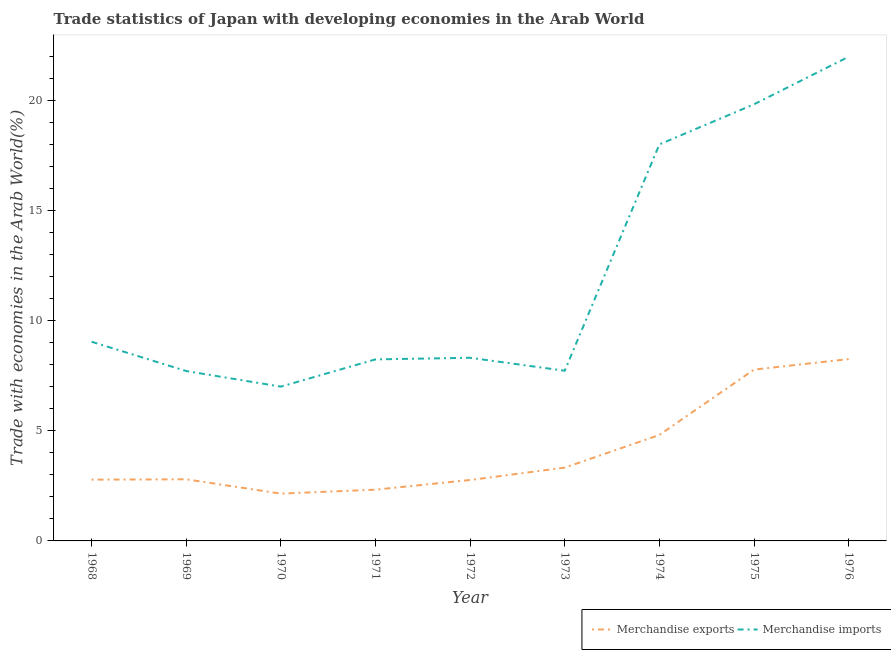Is the number of lines equal to the number of legend labels?
Provide a succinct answer. Yes. What is the merchandise imports in 1975?
Provide a succinct answer. 19.83. Across all years, what is the maximum merchandise imports?
Your response must be concise. 21.99. Across all years, what is the minimum merchandise exports?
Your answer should be very brief. 2.15. In which year was the merchandise imports maximum?
Ensure brevity in your answer.  1976. What is the total merchandise imports in the graph?
Offer a very short reply. 107.87. What is the difference between the merchandise exports in 1971 and that in 1976?
Provide a short and direct response. -5.93. What is the difference between the merchandise exports in 1975 and the merchandise imports in 1969?
Make the answer very short. 0.07. What is the average merchandise exports per year?
Make the answer very short. 4.11. In the year 1973, what is the difference between the merchandise exports and merchandise imports?
Offer a very short reply. -4.4. What is the ratio of the merchandise imports in 1969 to that in 1972?
Your answer should be compact. 0.93. What is the difference between the highest and the second highest merchandise exports?
Give a very brief answer. 0.48. What is the difference between the highest and the lowest merchandise exports?
Provide a succinct answer. 6.11. Is the sum of the merchandise imports in 1972 and 1974 greater than the maximum merchandise exports across all years?
Give a very brief answer. Yes. Does the merchandise exports monotonically increase over the years?
Give a very brief answer. No. What is the difference between two consecutive major ticks on the Y-axis?
Your response must be concise. 5. Are the values on the major ticks of Y-axis written in scientific E-notation?
Your answer should be very brief. No. Where does the legend appear in the graph?
Offer a very short reply. Bottom right. How many legend labels are there?
Keep it short and to the point. 2. How are the legend labels stacked?
Keep it short and to the point. Horizontal. What is the title of the graph?
Your answer should be very brief. Trade statistics of Japan with developing economies in the Arab World. What is the label or title of the Y-axis?
Keep it short and to the point. Trade with economies in the Arab World(%). What is the Trade with economies in the Arab World(%) in Merchandise exports in 1968?
Your answer should be very brief. 2.78. What is the Trade with economies in the Arab World(%) in Merchandise imports in 1968?
Make the answer very short. 9.04. What is the Trade with economies in the Arab World(%) in Merchandise exports in 1969?
Give a very brief answer. 2.8. What is the Trade with economies in the Arab World(%) in Merchandise imports in 1969?
Offer a very short reply. 7.71. What is the Trade with economies in the Arab World(%) of Merchandise exports in 1970?
Provide a short and direct response. 2.15. What is the Trade with economies in the Arab World(%) of Merchandise imports in 1970?
Give a very brief answer. 7.01. What is the Trade with economies in the Arab World(%) of Merchandise exports in 1971?
Your answer should be very brief. 2.33. What is the Trade with economies in the Arab World(%) in Merchandise imports in 1971?
Your answer should be compact. 8.24. What is the Trade with economies in the Arab World(%) in Merchandise exports in 1972?
Offer a very short reply. 2.77. What is the Trade with economies in the Arab World(%) in Merchandise imports in 1972?
Ensure brevity in your answer.  8.32. What is the Trade with economies in the Arab World(%) in Merchandise exports in 1973?
Ensure brevity in your answer.  3.33. What is the Trade with economies in the Arab World(%) of Merchandise imports in 1973?
Make the answer very short. 7.73. What is the Trade with economies in the Arab World(%) in Merchandise exports in 1974?
Provide a short and direct response. 4.81. What is the Trade with economies in the Arab World(%) in Merchandise imports in 1974?
Give a very brief answer. 18. What is the Trade with economies in the Arab World(%) in Merchandise exports in 1975?
Make the answer very short. 7.78. What is the Trade with economies in the Arab World(%) of Merchandise imports in 1975?
Make the answer very short. 19.83. What is the Trade with economies in the Arab World(%) in Merchandise exports in 1976?
Keep it short and to the point. 8.26. What is the Trade with economies in the Arab World(%) of Merchandise imports in 1976?
Give a very brief answer. 21.99. Across all years, what is the maximum Trade with economies in the Arab World(%) of Merchandise exports?
Offer a terse response. 8.26. Across all years, what is the maximum Trade with economies in the Arab World(%) in Merchandise imports?
Your answer should be very brief. 21.99. Across all years, what is the minimum Trade with economies in the Arab World(%) in Merchandise exports?
Offer a terse response. 2.15. Across all years, what is the minimum Trade with economies in the Arab World(%) in Merchandise imports?
Keep it short and to the point. 7.01. What is the total Trade with economies in the Arab World(%) in Merchandise exports in the graph?
Provide a succinct answer. 37. What is the total Trade with economies in the Arab World(%) of Merchandise imports in the graph?
Keep it short and to the point. 107.87. What is the difference between the Trade with economies in the Arab World(%) of Merchandise exports in 1968 and that in 1969?
Ensure brevity in your answer.  -0.01. What is the difference between the Trade with economies in the Arab World(%) in Merchandise imports in 1968 and that in 1969?
Make the answer very short. 1.33. What is the difference between the Trade with economies in the Arab World(%) in Merchandise exports in 1968 and that in 1970?
Make the answer very short. 0.64. What is the difference between the Trade with economies in the Arab World(%) of Merchandise imports in 1968 and that in 1970?
Ensure brevity in your answer.  2.04. What is the difference between the Trade with economies in the Arab World(%) of Merchandise exports in 1968 and that in 1971?
Your answer should be compact. 0.46. What is the difference between the Trade with economies in the Arab World(%) of Merchandise imports in 1968 and that in 1971?
Give a very brief answer. 0.8. What is the difference between the Trade with economies in the Arab World(%) in Merchandise exports in 1968 and that in 1972?
Offer a terse response. 0.02. What is the difference between the Trade with economies in the Arab World(%) of Merchandise imports in 1968 and that in 1972?
Make the answer very short. 0.73. What is the difference between the Trade with economies in the Arab World(%) in Merchandise exports in 1968 and that in 1973?
Your answer should be very brief. -0.55. What is the difference between the Trade with economies in the Arab World(%) of Merchandise imports in 1968 and that in 1973?
Provide a short and direct response. 1.32. What is the difference between the Trade with economies in the Arab World(%) of Merchandise exports in 1968 and that in 1974?
Offer a very short reply. -2.03. What is the difference between the Trade with economies in the Arab World(%) in Merchandise imports in 1968 and that in 1974?
Offer a very short reply. -8.96. What is the difference between the Trade with economies in the Arab World(%) of Merchandise exports in 1968 and that in 1975?
Provide a succinct answer. -5. What is the difference between the Trade with economies in the Arab World(%) of Merchandise imports in 1968 and that in 1975?
Your answer should be very brief. -10.78. What is the difference between the Trade with economies in the Arab World(%) of Merchandise exports in 1968 and that in 1976?
Give a very brief answer. -5.47. What is the difference between the Trade with economies in the Arab World(%) of Merchandise imports in 1968 and that in 1976?
Offer a very short reply. -12.94. What is the difference between the Trade with economies in the Arab World(%) of Merchandise exports in 1969 and that in 1970?
Give a very brief answer. 0.65. What is the difference between the Trade with economies in the Arab World(%) in Merchandise imports in 1969 and that in 1970?
Offer a terse response. 0.71. What is the difference between the Trade with economies in the Arab World(%) of Merchandise exports in 1969 and that in 1971?
Ensure brevity in your answer.  0.47. What is the difference between the Trade with economies in the Arab World(%) in Merchandise imports in 1969 and that in 1971?
Your answer should be very brief. -0.53. What is the difference between the Trade with economies in the Arab World(%) in Merchandise exports in 1969 and that in 1972?
Your answer should be very brief. 0.03. What is the difference between the Trade with economies in the Arab World(%) in Merchandise imports in 1969 and that in 1972?
Your answer should be compact. -0.6. What is the difference between the Trade with economies in the Arab World(%) of Merchandise exports in 1969 and that in 1973?
Your response must be concise. -0.53. What is the difference between the Trade with economies in the Arab World(%) in Merchandise imports in 1969 and that in 1973?
Provide a short and direct response. -0.01. What is the difference between the Trade with economies in the Arab World(%) of Merchandise exports in 1969 and that in 1974?
Offer a terse response. -2.01. What is the difference between the Trade with economies in the Arab World(%) in Merchandise imports in 1969 and that in 1974?
Your answer should be very brief. -10.29. What is the difference between the Trade with economies in the Arab World(%) in Merchandise exports in 1969 and that in 1975?
Make the answer very short. -4.98. What is the difference between the Trade with economies in the Arab World(%) of Merchandise imports in 1969 and that in 1975?
Ensure brevity in your answer.  -12.11. What is the difference between the Trade with economies in the Arab World(%) of Merchandise exports in 1969 and that in 1976?
Keep it short and to the point. -5.46. What is the difference between the Trade with economies in the Arab World(%) in Merchandise imports in 1969 and that in 1976?
Give a very brief answer. -14.27. What is the difference between the Trade with economies in the Arab World(%) in Merchandise exports in 1970 and that in 1971?
Your response must be concise. -0.18. What is the difference between the Trade with economies in the Arab World(%) in Merchandise imports in 1970 and that in 1971?
Give a very brief answer. -1.24. What is the difference between the Trade with economies in the Arab World(%) in Merchandise exports in 1970 and that in 1972?
Provide a succinct answer. -0.62. What is the difference between the Trade with economies in the Arab World(%) of Merchandise imports in 1970 and that in 1972?
Keep it short and to the point. -1.31. What is the difference between the Trade with economies in the Arab World(%) of Merchandise exports in 1970 and that in 1973?
Offer a terse response. -1.18. What is the difference between the Trade with economies in the Arab World(%) in Merchandise imports in 1970 and that in 1973?
Provide a succinct answer. -0.72. What is the difference between the Trade with economies in the Arab World(%) in Merchandise exports in 1970 and that in 1974?
Provide a succinct answer. -2.66. What is the difference between the Trade with economies in the Arab World(%) in Merchandise imports in 1970 and that in 1974?
Your response must be concise. -11. What is the difference between the Trade with economies in the Arab World(%) in Merchandise exports in 1970 and that in 1975?
Provide a short and direct response. -5.63. What is the difference between the Trade with economies in the Arab World(%) of Merchandise imports in 1970 and that in 1975?
Ensure brevity in your answer.  -12.82. What is the difference between the Trade with economies in the Arab World(%) of Merchandise exports in 1970 and that in 1976?
Offer a terse response. -6.11. What is the difference between the Trade with economies in the Arab World(%) in Merchandise imports in 1970 and that in 1976?
Make the answer very short. -14.98. What is the difference between the Trade with economies in the Arab World(%) of Merchandise exports in 1971 and that in 1972?
Ensure brevity in your answer.  -0.44. What is the difference between the Trade with economies in the Arab World(%) of Merchandise imports in 1971 and that in 1972?
Your answer should be very brief. -0.07. What is the difference between the Trade with economies in the Arab World(%) in Merchandise exports in 1971 and that in 1973?
Provide a succinct answer. -1. What is the difference between the Trade with economies in the Arab World(%) in Merchandise imports in 1971 and that in 1973?
Keep it short and to the point. 0.52. What is the difference between the Trade with economies in the Arab World(%) in Merchandise exports in 1971 and that in 1974?
Give a very brief answer. -2.48. What is the difference between the Trade with economies in the Arab World(%) of Merchandise imports in 1971 and that in 1974?
Your answer should be very brief. -9.76. What is the difference between the Trade with economies in the Arab World(%) in Merchandise exports in 1971 and that in 1975?
Give a very brief answer. -5.45. What is the difference between the Trade with economies in the Arab World(%) in Merchandise imports in 1971 and that in 1975?
Your answer should be compact. -11.58. What is the difference between the Trade with economies in the Arab World(%) of Merchandise exports in 1971 and that in 1976?
Your response must be concise. -5.93. What is the difference between the Trade with economies in the Arab World(%) of Merchandise imports in 1971 and that in 1976?
Offer a terse response. -13.74. What is the difference between the Trade with economies in the Arab World(%) of Merchandise exports in 1972 and that in 1973?
Give a very brief answer. -0.56. What is the difference between the Trade with economies in the Arab World(%) in Merchandise imports in 1972 and that in 1973?
Keep it short and to the point. 0.59. What is the difference between the Trade with economies in the Arab World(%) in Merchandise exports in 1972 and that in 1974?
Your answer should be very brief. -2.05. What is the difference between the Trade with economies in the Arab World(%) in Merchandise imports in 1972 and that in 1974?
Make the answer very short. -9.69. What is the difference between the Trade with economies in the Arab World(%) in Merchandise exports in 1972 and that in 1975?
Your response must be concise. -5.01. What is the difference between the Trade with economies in the Arab World(%) of Merchandise imports in 1972 and that in 1975?
Ensure brevity in your answer.  -11.51. What is the difference between the Trade with economies in the Arab World(%) of Merchandise exports in 1972 and that in 1976?
Offer a terse response. -5.49. What is the difference between the Trade with economies in the Arab World(%) in Merchandise imports in 1972 and that in 1976?
Your answer should be very brief. -13.67. What is the difference between the Trade with economies in the Arab World(%) of Merchandise exports in 1973 and that in 1974?
Your answer should be compact. -1.48. What is the difference between the Trade with economies in the Arab World(%) in Merchandise imports in 1973 and that in 1974?
Give a very brief answer. -10.28. What is the difference between the Trade with economies in the Arab World(%) of Merchandise exports in 1973 and that in 1975?
Your answer should be very brief. -4.45. What is the difference between the Trade with economies in the Arab World(%) of Merchandise imports in 1973 and that in 1975?
Make the answer very short. -12.1. What is the difference between the Trade with economies in the Arab World(%) of Merchandise exports in 1973 and that in 1976?
Provide a succinct answer. -4.93. What is the difference between the Trade with economies in the Arab World(%) in Merchandise imports in 1973 and that in 1976?
Ensure brevity in your answer.  -14.26. What is the difference between the Trade with economies in the Arab World(%) in Merchandise exports in 1974 and that in 1975?
Make the answer very short. -2.97. What is the difference between the Trade with economies in the Arab World(%) of Merchandise imports in 1974 and that in 1975?
Keep it short and to the point. -1.82. What is the difference between the Trade with economies in the Arab World(%) in Merchandise exports in 1974 and that in 1976?
Make the answer very short. -3.44. What is the difference between the Trade with economies in the Arab World(%) of Merchandise imports in 1974 and that in 1976?
Offer a very short reply. -3.98. What is the difference between the Trade with economies in the Arab World(%) in Merchandise exports in 1975 and that in 1976?
Your answer should be very brief. -0.48. What is the difference between the Trade with economies in the Arab World(%) in Merchandise imports in 1975 and that in 1976?
Offer a terse response. -2.16. What is the difference between the Trade with economies in the Arab World(%) in Merchandise exports in 1968 and the Trade with economies in the Arab World(%) in Merchandise imports in 1969?
Keep it short and to the point. -4.93. What is the difference between the Trade with economies in the Arab World(%) in Merchandise exports in 1968 and the Trade with economies in the Arab World(%) in Merchandise imports in 1970?
Ensure brevity in your answer.  -4.22. What is the difference between the Trade with economies in the Arab World(%) of Merchandise exports in 1968 and the Trade with economies in the Arab World(%) of Merchandise imports in 1971?
Offer a terse response. -5.46. What is the difference between the Trade with economies in the Arab World(%) of Merchandise exports in 1968 and the Trade with economies in the Arab World(%) of Merchandise imports in 1972?
Your response must be concise. -5.53. What is the difference between the Trade with economies in the Arab World(%) of Merchandise exports in 1968 and the Trade with economies in the Arab World(%) of Merchandise imports in 1973?
Keep it short and to the point. -4.94. What is the difference between the Trade with economies in the Arab World(%) of Merchandise exports in 1968 and the Trade with economies in the Arab World(%) of Merchandise imports in 1974?
Your response must be concise. -15.22. What is the difference between the Trade with economies in the Arab World(%) of Merchandise exports in 1968 and the Trade with economies in the Arab World(%) of Merchandise imports in 1975?
Your response must be concise. -17.04. What is the difference between the Trade with economies in the Arab World(%) of Merchandise exports in 1968 and the Trade with economies in the Arab World(%) of Merchandise imports in 1976?
Give a very brief answer. -19.2. What is the difference between the Trade with economies in the Arab World(%) in Merchandise exports in 1969 and the Trade with economies in the Arab World(%) in Merchandise imports in 1970?
Give a very brief answer. -4.21. What is the difference between the Trade with economies in the Arab World(%) of Merchandise exports in 1969 and the Trade with economies in the Arab World(%) of Merchandise imports in 1971?
Your answer should be very brief. -5.45. What is the difference between the Trade with economies in the Arab World(%) of Merchandise exports in 1969 and the Trade with economies in the Arab World(%) of Merchandise imports in 1972?
Provide a succinct answer. -5.52. What is the difference between the Trade with economies in the Arab World(%) in Merchandise exports in 1969 and the Trade with economies in the Arab World(%) in Merchandise imports in 1973?
Your answer should be very brief. -4.93. What is the difference between the Trade with economies in the Arab World(%) of Merchandise exports in 1969 and the Trade with economies in the Arab World(%) of Merchandise imports in 1974?
Give a very brief answer. -15.21. What is the difference between the Trade with economies in the Arab World(%) of Merchandise exports in 1969 and the Trade with economies in the Arab World(%) of Merchandise imports in 1975?
Make the answer very short. -17.03. What is the difference between the Trade with economies in the Arab World(%) of Merchandise exports in 1969 and the Trade with economies in the Arab World(%) of Merchandise imports in 1976?
Make the answer very short. -19.19. What is the difference between the Trade with economies in the Arab World(%) in Merchandise exports in 1970 and the Trade with economies in the Arab World(%) in Merchandise imports in 1971?
Keep it short and to the point. -6.09. What is the difference between the Trade with economies in the Arab World(%) in Merchandise exports in 1970 and the Trade with economies in the Arab World(%) in Merchandise imports in 1972?
Give a very brief answer. -6.17. What is the difference between the Trade with economies in the Arab World(%) of Merchandise exports in 1970 and the Trade with economies in the Arab World(%) of Merchandise imports in 1973?
Your response must be concise. -5.58. What is the difference between the Trade with economies in the Arab World(%) in Merchandise exports in 1970 and the Trade with economies in the Arab World(%) in Merchandise imports in 1974?
Make the answer very short. -15.86. What is the difference between the Trade with economies in the Arab World(%) of Merchandise exports in 1970 and the Trade with economies in the Arab World(%) of Merchandise imports in 1975?
Offer a terse response. -17.68. What is the difference between the Trade with economies in the Arab World(%) of Merchandise exports in 1970 and the Trade with economies in the Arab World(%) of Merchandise imports in 1976?
Offer a terse response. -19.84. What is the difference between the Trade with economies in the Arab World(%) in Merchandise exports in 1971 and the Trade with economies in the Arab World(%) in Merchandise imports in 1972?
Keep it short and to the point. -5.99. What is the difference between the Trade with economies in the Arab World(%) of Merchandise exports in 1971 and the Trade with economies in the Arab World(%) of Merchandise imports in 1973?
Ensure brevity in your answer.  -5.4. What is the difference between the Trade with economies in the Arab World(%) of Merchandise exports in 1971 and the Trade with economies in the Arab World(%) of Merchandise imports in 1974?
Your answer should be very brief. -15.68. What is the difference between the Trade with economies in the Arab World(%) in Merchandise exports in 1971 and the Trade with economies in the Arab World(%) in Merchandise imports in 1975?
Offer a terse response. -17.5. What is the difference between the Trade with economies in the Arab World(%) in Merchandise exports in 1971 and the Trade with economies in the Arab World(%) in Merchandise imports in 1976?
Ensure brevity in your answer.  -19.66. What is the difference between the Trade with economies in the Arab World(%) in Merchandise exports in 1972 and the Trade with economies in the Arab World(%) in Merchandise imports in 1973?
Offer a very short reply. -4.96. What is the difference between the Trade with economies in the Arab World(%) in Merchandise exports in 1972 and the Trade with economies in the Arab World(%) in Merchandise imports in 1974?
Give a very brief answer. -15.24. What is the difference between the Trade with economies in the Arab World(%) in Merchandise exports in 1972 and the Trade with economies in the Arab World(%) in Merchandise imports in 1975?
Provide a succinct answer. -17.06. What is the difference between the Trade with economies in the Arab World(%) in Merchandise exports in 1972 and the Trade with economies in the Arab World(%) in Merchandise imports in 1976?
Give a very brief answer. -19.22. What is the difference between the Trade with economies in the Arab World(%) in Merchandise exports in 1973 and the Trade with economies in the Arab World(%) in Merchandise imports in 1974?
Provide a short and direct response. -14.68. What is the difference between the Trade with economies in the Arab World(%) in Merchandise exports in 1973 and the Trade with economies in the Arab World(%) in Merchandise imports in 1975?
Your answer should be very brief. -16.5. What is the difference between the Trade with economies in the Arab World(%) of Merchandise exports in 1973 and the Trade with economies in the Arab World(%) of Merchandise imports in 1976?
Provide a succinct answer. -18.66. What is the difference between the Trade with economies in the Arab World(%) in Merchandise exports in 1974 and the Trade with economies in the Arab World(%) in Merchandise imports in 1975?
Make the answer very short. -15.01. What is the difference between the Trade with economies in the Arab World(%) of Merchandise exports in 1974 and the Trade with economies in the Arab World(%) of Merchandise imports in 1976?
Your response must be concise. -17.17. What is the difference between the Trade with economies in the Arab World(%) in Merchandise exports in 1975 and the Trade with economies in the Arab World(%) in Merchandise imports in 1976?
Make the answer very short. -14.21. What is the average Trade with economies in the Arab World(%) of Merchandise exports per year?
Your answer should be very brief. 4.11. What is the average Trade with economies in the Arab World(%) of Merchandise imports per year?
Offer a terse response. 11.99. In the year 1968, what is the difference between the Trade with economies in the Arab World(%) of Merchandise exports and Trade with economies in the Arab World(%) of Merchandise imports?
Your answer should be compact. -6.26. In the year 1969, what is the difference between the Trade with economies in the Arab World(%) of Merchandise exports and Trade with economies in the Arab World(%) of Merchandise imports?
Your response must be concise. -4.92. In the year 1970, what is the difference between the Trade with economies in the Arab World(%) in Merchandise exports and Trade with economies in the Arab World(%) in Merchandise imports?
Your answer should be very brief. -4.86. In the year 1971, what is the difference between the Trade with economies in the Arab World(%) of Merchandise exports and Trade with economies in the Arab World(%) of Merchandise imports?
Give a very brief answer. -5.92. In the year 1972, what is the difference between the Trade with economies in the Arab World(%) in Merchandise exports and Trade with economies in the Arab World(%) in Merchandise imports?
Your answer should be compact. -5.55. In the year 1973, what is the difference between the Trade with economies in the Arab World(%) of Merchandise exports and Trade with economies in the Arab World(%) of Merchandise imports?
Ensure brevity in your answer.  -4.4. In the year 1974, what is the difference between the Trade with economies in the Arab World(%) of Merchandise exports and Trade with economies in the Arab World(%) of Merchandise imports?
Give a very brief answer. -13.19. In the year 1975, what is the difference between the Trade with economies in the Arab World(%) in Merchandise exports and Trade with economies in the Arab World(%) in Merchandise imports?
Your answer should be very brief. -12.05. In the year 1976, what is the difference between the Trade with economies in the Arab World(%) of Merchandise exports and Trade with economies in the Arab World(%) of Merchandise imports?
Your answer should be very brief. -13.73. What is the ratio of the Trade with economies in the Arab World(%) in Merchandise exports in 1968 to that in 1969?
Your answer should be very brief. 0.99. What is the ratio of the Trade with economies in the Arab World(%) of Merchandise imports in 1968 to that in 1969?
Keep it short and to the point. 1.17. What is the ratio of the Trade with economies in the Arab World(%) in Merchandise exports in 1968 to that in 1970?
Provide a short and direct response. 1.3. What is the ratio of the Trade with economies in the Arab World(%) in Merchandise imports in 1968 to that in 1970?
Give a very brief answer. 1.29. What is the ratio of the Trade with economies in the Arab World(%) of Merchandise exports in 1968 to that in 1971?
Give a very brief answer. 1.2. What is the ratio of the Trade with economies in the Arab World(%) of Merchandise imports in 1968 to that in 1971?
Provide a short and direct response. 1.1. What is the ratio of the Trade with economies in the Arab World(%) in Merchandise imports in 1968 to that in 1972?
Your answer should be very brief. 1.09. What is the ratio of the Trade with economies in the Arab World(%) of Merchandise exports in 1968 to that in 1973?
Give a very brief answer. 0.84. What is the ratio of the Trade with economies in the Arab World(%) of Merchandise imports in 1968 to that in 1973?
Your answer should be compact. 1.17. What is the ratio of the Trade with economies in the Arab World(%) of Merchandise exports in 1968 to that in 1974?
Your answer should be very brief. 0.58. What is the ratio of the Trade with economies in the Arab World(%) of Merchandise imports in 1968 to that in 1974?
Give a very brief answer. 0.5. What is the ratio of the Trade with economies in the Arab World(%) in Merchandise exports in 1968 to that in 1975?
Keep it short and to the point. 0.36. What is the ratio of the Trade with economies in the Arab World(%) of Merchandise imports in 1968 to that in 1975?
Your answer should be very brief. 0.46. What is the ratio of the Trade with economies in the Arab World(%) in Merchandise exports in 1968 to that in 1976?
Make the answer very short. 0.34. What is the ratio of the Trade with economies in the Arab World(%) in Merchandise imports in 1968 to that in 1976?
Keep it short and to the point. 0.41. What is the ratio of the Trade with economies in the Arab World(%) of Merchandise exports in 1969 to that in 1970?
Keep it short and to the point. 1.3. What is the ratio of the Trade with economies in the Arab World(%) of Merchandise imports in 1969 to that in 1970?
Ensure brevity in your answer.  1.1. What is the ratio of the Trade with economies in the Arab World(%) in Merchandise exports in 1969 to that in 1971?
Ensure brevity in your answer.  1.2. What is the ratio of the Trade with economies in the Arab World(%) of Merchandise imports in 1969 to that in 1971?
Give a very brief answer. 0.94. What is the ratio of the Trade with economies in the Arab World(%) in Merchandise exports in 1969 to that in 1972?
Your answer should be very brief. 1.01. What is the ratio of the Trade with economies in the Arab World(%) in Merchandise imports in 1969 to that in 1972?
Make the answer very short. 0.93. What is the ratio of the Trade with economies in the Arab World(%) in Merchandise exports in 1969 to that in 1973?
Your response must be concise. 0.84. What is the ratio of the Trade with economies in the Arab World(%) of Merchandise imports in 1969 to that in 1973?
Provide a succinct answer. 1. What is the ratio of the Trade with economies in the Arab World(%) of Merchandise exports in 1969 to that in 1974?
Make the answer very short. 0.58. What is the ratio of the Trade with economies in the Arab World(%) of Merchandise imports in 1969 to that in 1974?
Your answer should be compact. 0.43. What is the ratio of the Trade with economies in the Arab World(%) of Merchandise exports in 1969 to that in 1975?
Your answer should be very brief. 0.36. What is the ratio of the Trade with economies in the Arab World(%) in Merchandise imports in 1969 to that in 1975?
Provide a succinct answer. 0.39. What is the ratio of the Trade with economies in the Arab World(%) of Merchandise exports in 1969 to that in 1976?
Your answer should be compact. 0.34. What is the ratio of the Trade with economies in the Arab World(%) of Merchandise imports in 1969 to that in 1976?
Offer a terse response. 0.35. What is the ratio of the Trade with economies in the Arab World(%) in Merchandise imports in 1970 to that in 1971?
Make the answer very short. 0.85. What is the ratio of the Trade with economies in the Arab World(%) of Merchandise exports in 1970 to that in 1972?
Give a very brief answer. 0.78. What is the ratio of the Trade with economies in the Arab World(%) in Merchandise imports in 1970 to that in 1972?
Ensure brevity in your answer.  0.84. What is the ratio of the Trade with economies in the Arab World(%) in Merchandise exports in 1970 to that in 1973?
Your answer should be compact. 0.65. What is the ratio of the Trade with economies in the Arab World(%) in Merchandise imports in 1970 to that in 1973?
Ensure brevity in your answer.  0.91. What is the ratio of the Trade with economies in the Arab World(%) of Merchandise exports in 1970 to that in 1974?
Ensure brevity in your answer.  0.45. What is the ratio of the Trade with economies in the Arab World(%) of Merchandise imports in 1970 to that in 1974?
Your answer should be very brief. 0.39. What is the ratio of the Trade with economies in the Arab World(%) in Merchandise exports in 1970 to that in 1975?
Keep it short and to the point. 0.28. What is the ratio of the Trade with economies in the Arab World(%) of Merchandise imports in 1970 to that in 1975?
Keep it short and to the point. 0.35. What is the ratio of the Trade with economies in the Arab World(%) in Merchandise exports in 1970 to that in 1976?
Give a very brief answer. 0.26. What is the ratio of the Trade with economies in the Arab World(%) in Merchandise imports in 1970 to that in 1976?
Provide a succinct answer. 0.32. What is the ratio of the Trade with economies in the Arab World(%) in Merchandise exports in 1971 to that in 1972?
Ensure brevity in your answer.  0.84. What is the ratio of the Trade with economies in the Arab World(%) in Merchandise exports in 1971 to that in 1973?
Your answer should be compact. 0.7. What is the ratio of the Trade with economies in the Arab World(%) of Merchandise imports in 1971 to that in 1973?
Provide a succinct answer. 1.07. What is the ratio of the Trade with economies in the Arab World(%) in Merchandise exports in 1971 to that in 1974?
Ensure brevity in your answer.  0.48. What is the ratio of the Trade with economies in the Arab World(%) in Merchandise imports in 1971 to that in 1974?
Ensure brevity in your answer.  0.46. What is the ratio of the Trade with economies in the Arab World(%) in Merchandise exports in 1971 to that in 1975?
Provide a short and direct response. 0.3. What is the ratio of the Trade with economies in the Arab World(%) in Merchandise imports in 1971 to that in 1975?
Ensure brevity in your answer.  0.42. What is the ratio of the Trade with economies in the Arab World(%) in Merchandise exports in 1971 to that in 1976?
Give a very brief answer. 0.28. What is the ratio of the Trade with economies in the Arab World(%) in Merchandise imports in 1971 to that in 1976?
Ensure brevity in your answer.  0.37. What is the ratio of the Trade with economies in the Arab World(%) of Merchandise exports in 1972 to that in 1973?
Give a very brief answer. 0.83. What is the ratio of the Trade with economies in the Arab World(%) in Merchandise imports in 1972 to that in 1973?
Offer a terse response. 1.08. What is the ratio of the Trade with economies in the Arab World(%) of Merchandise exports in 1972 to that in 1974?
Offer a terse response. 0.57. What is the ratio of the Trade with economies in the Arab World(%) of Merchandise imports in 1972 to that in 1974?
Keep it short and to the point. 0.46. What is the ratio of the Trade with economies in the Arab World(%) of Merchandise exports in 1972 to that in 1975?
Provide a short and direct response. 0.36. What is the ratio of the Trade with economies in the Arab World(%) of Merchandise imports in 1972 to that in 1975?
Your response must be concise. 0.42. What is the ratio of the Trade with economies in the Arab World(%) in Merchandise exports in 1972 to that in 1976?
Offer a very short reply. 0.34. What is the ratio of the Trade with economies in the Arab World(%) in Merchandise imports in 1972 to that in 1976?
Your response must be concise. 0.38. What is the ratio of the Trade with economies in the Arab World(%) of Merchandise exports in 1973 to that in 1974?
Offer a very short reply. 0.69. What is the ratio of the Trade with economies in the Arab World(%) of Merchandise imports in 1973 to that in 1974?
Provide a succinct answer. 0.43. What is the ratio of the Trade with economies in the Arab World(%) of Merchandise exports in 1973 to that in 1975?
Make the answer very short. 0.43. What is the ratio of the Trade with economies in the Arab World(%) of Merchandise imports in 1973 to that in 1975?
Offer a very short reply. 0.39. What is the ratio of the Trade with economies in the Arab World(%) in Merchandise exports in 1973 to that in 1976?
Your answer should be very brief. 0.4. What is the ratio of the Trade with economies in the Arab World(%) in Merchandise imports in 1973 to that in 1976?
Ensure brevity in your answer.  0.35. What is the ratio of the Trade with economies in the Arab World(%) in Merchandise exports in 1974 to that in 1975?
Ensure brevity in your answer.  0.62. What is the ratio of the Trade with economies in the Arab World(%) of Merchandise imports in 1974 to that in 1975?
Offer a very short reply. 0.91. What is the ratio of the Trade with economies in the Arab World(%) of Merchandise exports in 1974 to that in 1976?
Give a very brief answer. 0.58. What is the ratio of the Trade with economies in the Arab World(%) in Merchandise imports in 1974 to that in 1976?
Keep it short and to the point. 0.82. What is the ratio of the Trade with economies in the Arab World(%) in Merchandise exports in 1975 to that in 1976?
Keep it short and to the point. 0.94. What is the ratio of the Trade with economies in the Arab World(%) of Merchandise imports in 1975 to that in 1976?
Offer a terse response. 0.9. What is the difference between the highest and the second highest Trade with economies in the Arab World(%) in Merchandise exports?
Offer a very short reply. 0.48. What is the difference between the highest and the second highest Trade with economies in the Arab World(%) in Merchandise imports?
Your answer should be compact. 2.16. What is the difference between the highest and the lowest Trade with economies in the Arab World(%) in Merchandise exports?
Ensure brevity in your answer.  6.11. What is the difference between the highest and the lowest Trade with economies in the Arab World(%) of Merchandise imports?
Offer a very short reply. 14.98. 